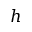Convert formula to latex. <formula><loc_0><loc_0><loc_500><loc_500>h</formula> 